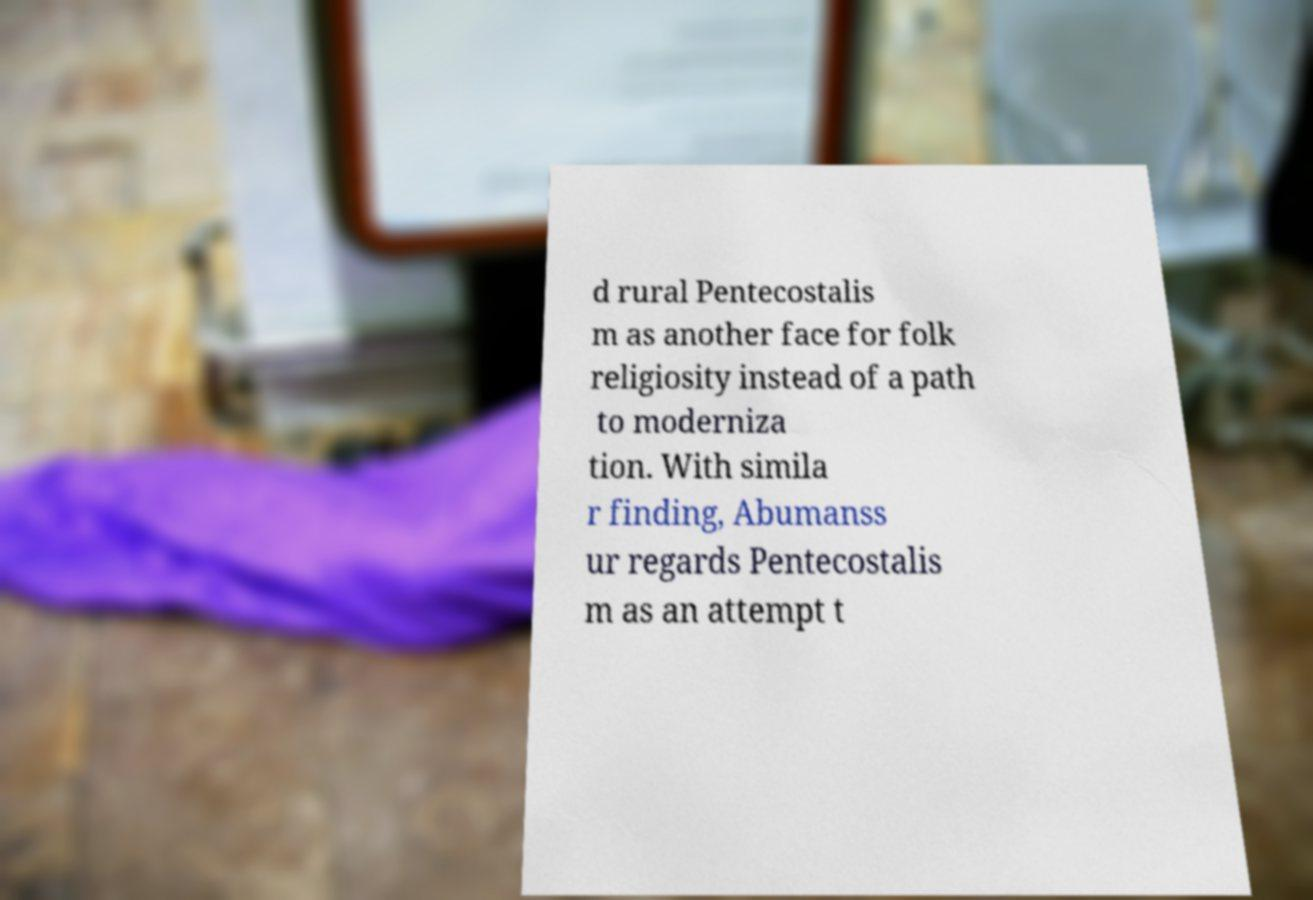For documentation purposes, I need the text within this image transcribed. Could you provide that? d rural Pentecostalis m as another face for folk religiosity instead of a path to moderniza tion. With simila r finding, Abumanss ur regards Pentecostalis m as an attempt t 